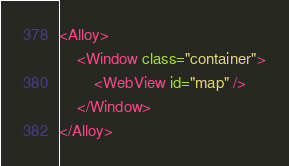Convert code to text. <code><loc_0><loc_0><loc_500><loc_500><_XML_><Alloy>
	<Window class="container">
		<WebView id="map" />
	</Window>
</Alloy>
</code> 